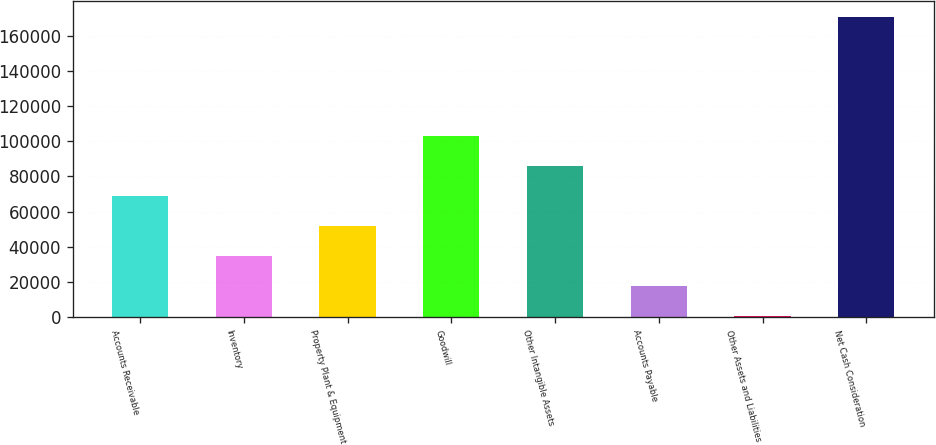Convert chart. <chart><loc_0><loc_0><loc_500><loc_500><bar_chart><fcel>Accounts Receivable<fcel>Inventory<fcel>Property Plant & Equipment<fcel>Goodwill<fcel>Other Intangible Assets<fcel>Accounts Payable<fcel>Other Assets and Liabilities<fcel>Net Cash Consideration<nl><fcel>68706.8<fcel>34653.4<fcel>51680.1<fcel>102760<fcel>85733.5<fcel>17626.7<fcel>600<fcel>170867<nl></chart> 